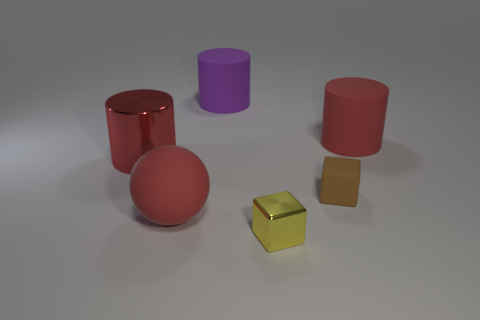The rubber cylinder that is the same color as the matte ball is what size?
Provide a short and direct response. Large. What number of other objects are the same shape as the brown rubber thing?
Your answer should be compact. 1. What number of large shiny cylinders are the same color as the rubber sphere?
Your answer should be compact. 1. Do the red rubber ball and the red matte cylinder have the same size?
Provide a succinct answer. Yes. There is a rubber thing that is left of the yellow object and to the right of the ball; what is its color?
Your answer should be very brief. Purple. What number of other yellow blocks have the same material as the tiny yellow cube?
Your answer should be compact. 0. How many blue spheres are there?
Keep it short and to the point. 0. Does the red matte cylinder have the same size as the metallic object to the left of the purple object?
Offer a terse response. Yes. What material is the red thing behind the large red cylinder that is to the left of the tiny metal thing made of?
Offer a very short reply. Rubber. How big is the cube in front of the red matte thing that is to the left of the small thing in front of the red rubber ball?
Your answer should be compact. Small. 